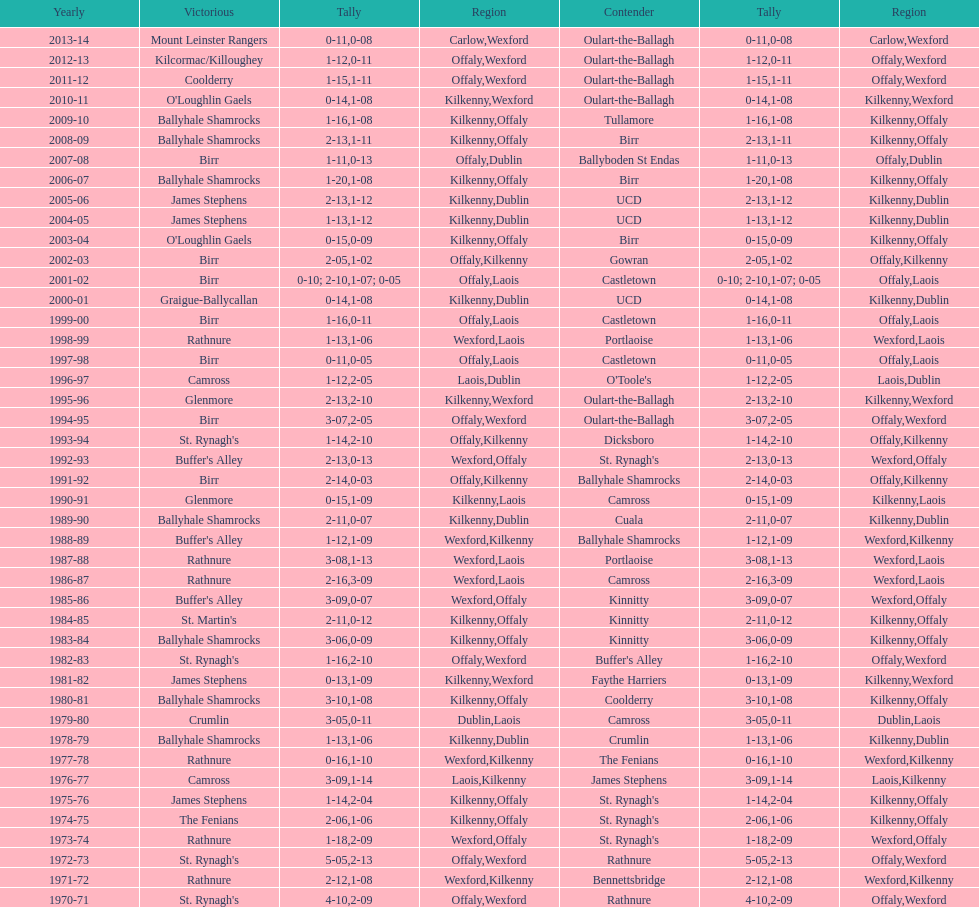In which final season did the leinster senior club hurling championships have a winning margin of less than 11 points? 2007-08. 